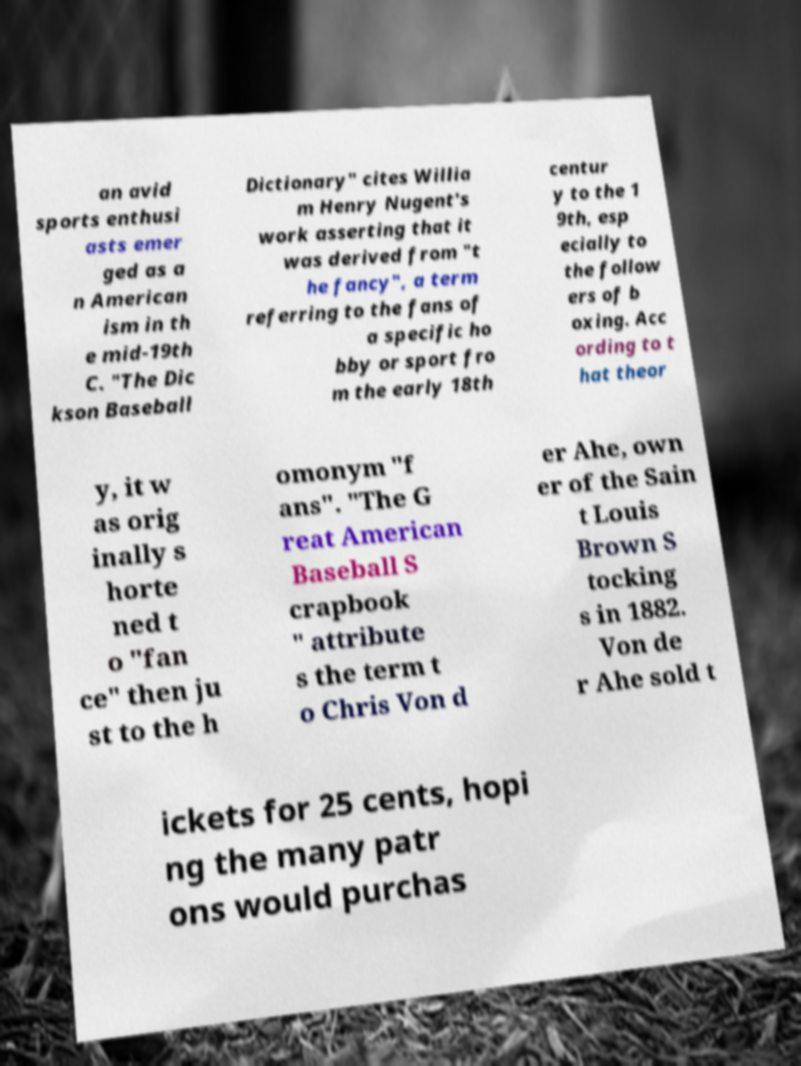What messages or text are displayed in this image? I need them in a readable, typed format. an avid sports enthusi asts emer ged as a n American ism in th e mid-19th C. "The Dic kson Baseball Dictionary" cites Willia m Henry Nugent's work asserting that it was derived from "t he fancy", a term referring to the fans of a specific ho bby or sport fro m the early 18th centur y to the 1 9th, esp ecially to the follow ers of b oxing. Acc ording to t hat theor y, it w as orig inally s horte ned t o "fan ce" then ju st to the h omonym "f ans". "The G reat American Baseball S crapbook " attribute s the term t o Chris Von d er Ahe, own er of the Sain t Louis Brown S tocking s in 1882. Von de r Ahe sold t ickets for 25 cents, hopi ng the many patr ons would purchas 